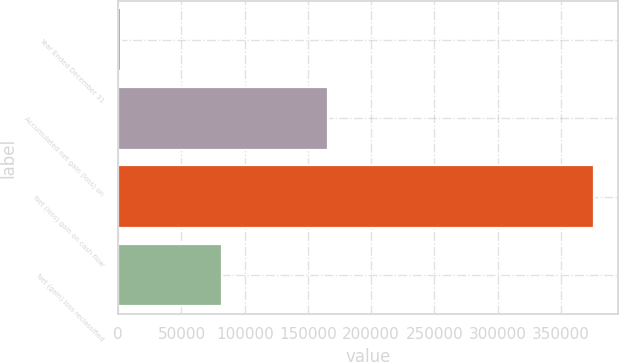<chart> <loc_0><loc_0><loc_500><loc_500><bar_chart><fcel>Year Ended December 31<fcel>Accumulated net gain (loss) on<fcel>Net (loss) gain on cash flow<fcel>Net (gain) loss reclassified<nl><fcel>2009<fcel>166028<fcel>376128<fcel>82092<nl></chart> 